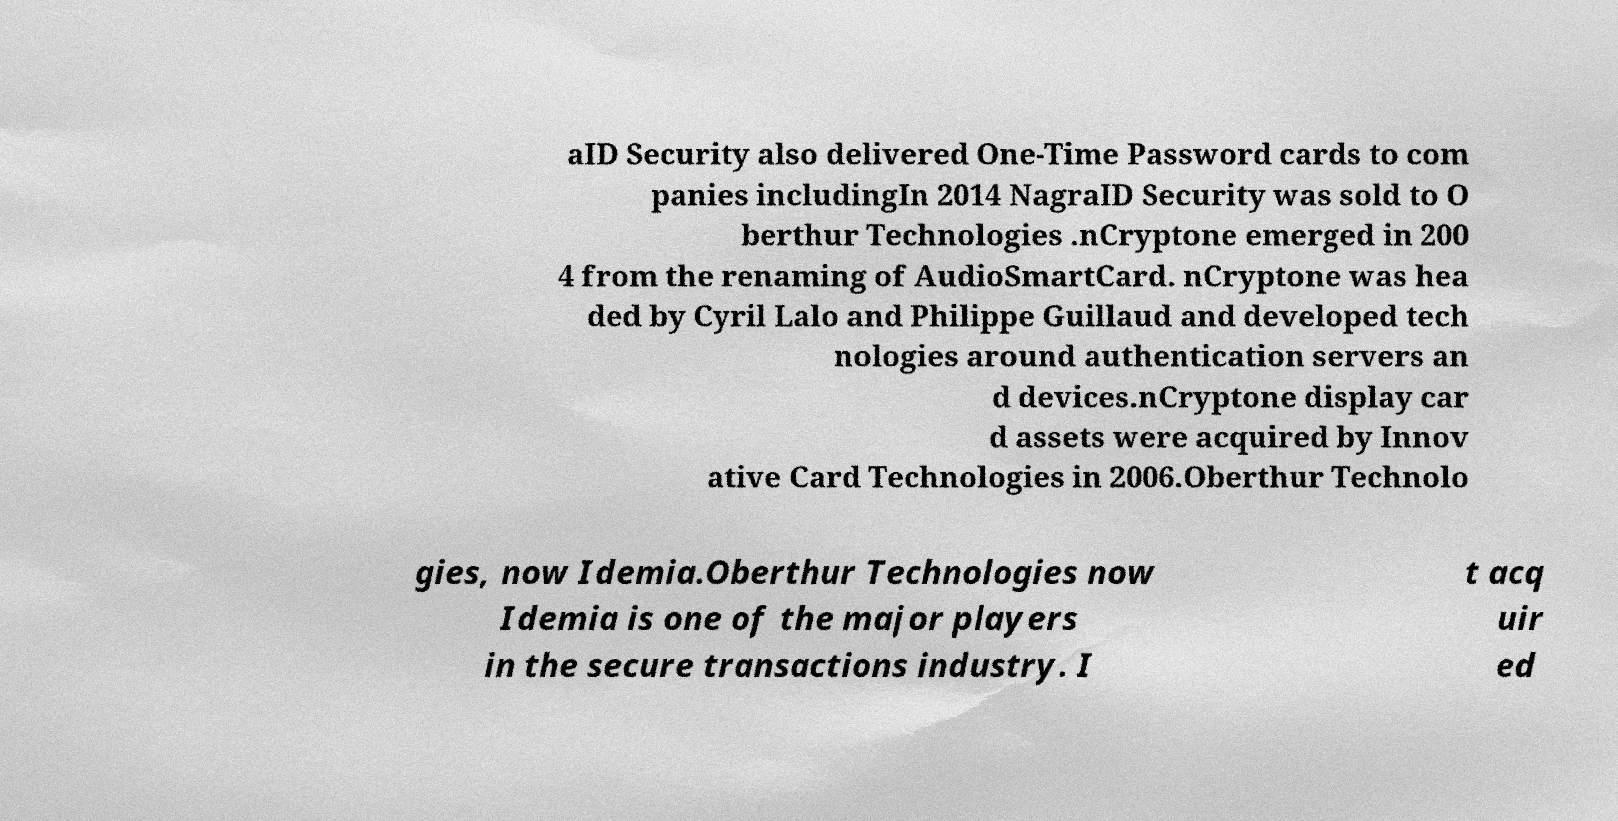Can you read and provide the text displayed in the image?This photo seems to have some interesting text. Can you extract and type it out for me? aID Security also delivered One-Time Password cards to com panies includingIn 2014 NagraID Security was sold to O berthur Technologies .nCryptone emerged in 200 4 from the renaming of AudioSmartCard. nCryptone was hea ded by Cyril Lalo and Philippe Guillaud and developed tech nologies around authentication servers an d devices.nCryptone display car d assets were acquired by Innov ative Card Technologies in 2006.Oberthur Technolo gies, now Idemia.Oberthur Technologies now Idemia is one of the major players in the secure transactions industry. I t acq uir ed 